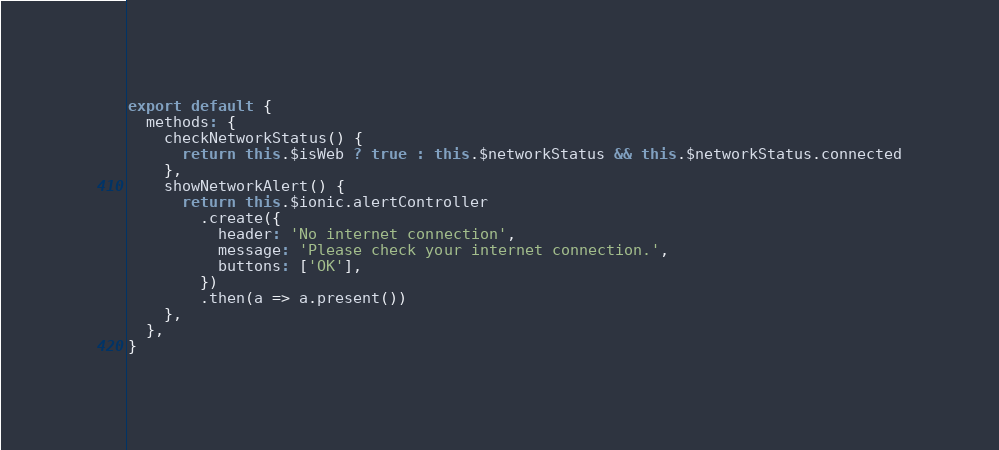Convert code to text. <code><loc_0><loc_0><loc_500><loc_500><_JavaScript_>export default {
  methods: {
    checkNetworkStatus() {
      return this.$isWeb ? true : this.$networkStatus && this.$networkStatus.connected
    },
    showNetworkAlert() {
      return this.$ionic.alertController
        .create({
          header: 'No internet connection',
          message: 'Please check your internet connection.',
          buttons: ['OK'],
        })
        .then(a => a.present())
    },
  },
}
</code> 